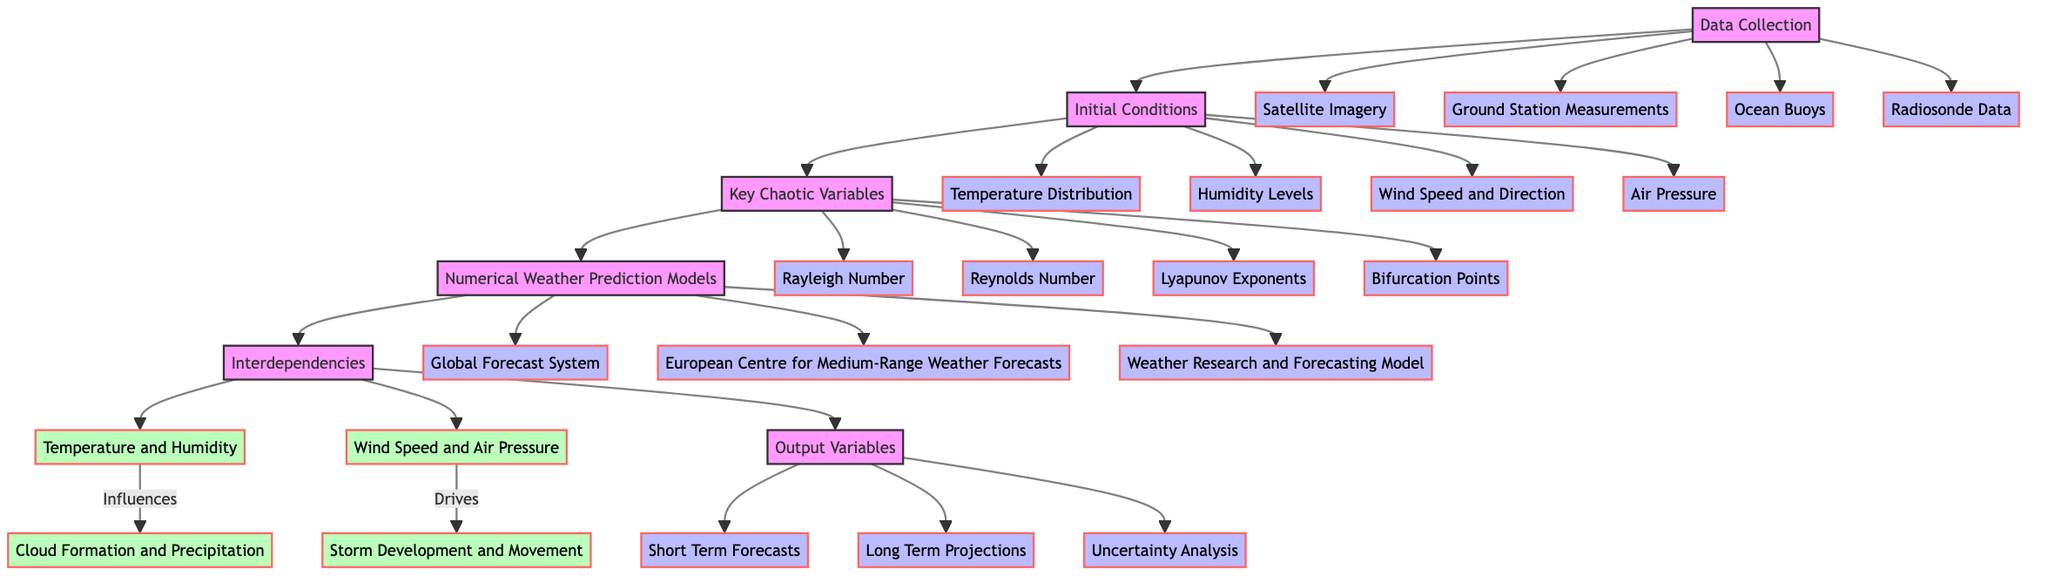What are the subcomponents of Data Collection? According to the diagram, Data Collection has four subcomponents: Satellite Imagery, Ground Station Measurements, Ocean Buoys, and Radiosonde Data.
Answer: Satellite Imagery, Ground Station Measurements, Ocean Buoys, Radiosonde Data How many key chaotic variables are there? The diagram lists four key chaotic variables: Rayleigh Number, Reynolds Number, Lyapunov Exponents, and Bifurcation Points. Therefore, the number of key chaotic variables is four.
Answer: Four What influences cloud formation and precipitation? The diagram indicates that the relationship between Temperature and Humidity influences cloud formation and precipitation. Specifically, this relationship is highlighted within the Interdependencies block.
Answer: Temperature and Humidity What is the output of the Numerical Weather Prediction Models block? The output from the Numerical Weather Prediction Models block leads to the Interdependencies block, affecting output variables such as Short Term Forecasts, Long Term Projections, and Uncertainty Analysis. Thus, the output includes these three components.
Answer: Short Term Forecasts, Long Term Projections, Uncertainty Analysis Which model is included in the Numerical Weather Prediction Models? From the diagram, the three models listed under Numerical Weather Prediction Models are the Global Forecast System, European Centre for Medium-Range Weather Forecasts, and Weather Research and Forecasting Model.
Answer: Global Forecast System, European Centre for Medium-Range Weather Forecasts, Weather Research and Forecasting Model What drives storm development and movement? The diagram shows that Wind Speed and Air Pressure drive storm development and movement, which is categorized under the Interdependencies section.
Answer: Wind Speed and Air Pressure Which component impacts initial conditions? The diagram indicates that Data Collection directly influences Initial Conditions, as shown by the arrow connecting these two blocks.
Answer: Data Collection How many interdependencies are identified in the diagram? The diagram specifies two interdependencies: one between Temperature and Humidity and the other between Wind Speed and Air Pressure. Therefore, there are two interdependencies identified.
Answer: Two 